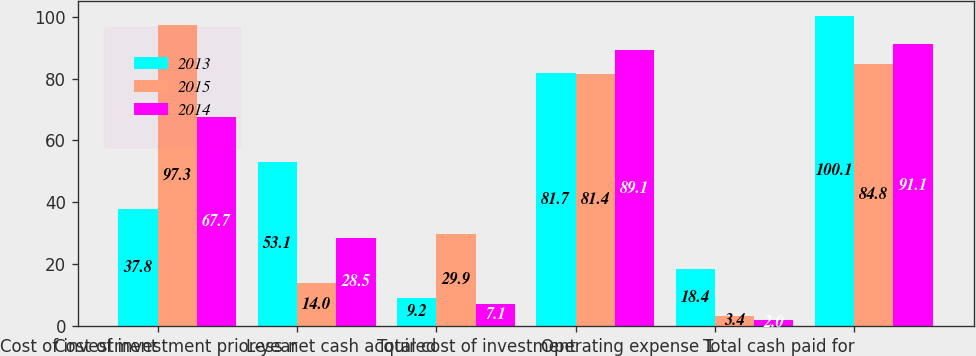<chart> <loc_0><loc_0><loc_500><loc_500><stacked_bar_chart><ecel><fcel>Cost of investment<fcel>Cost of investment prior-year<fcel>Less net cash acquired<fcel>Total cost of investment<fcel>Operating expense 1<fcel>Total cash paid for<nl><fcel>2013<fcel>37.8<fcel>53.1<fcel>9.2<fcel>81.7<fcel>18.4<fcel>100.1<nl><fcel>2015<fcel>97.3<fcel>14<fcel>29.9<fcel>81.4<fcel>3.4<fcel>84.8<nl><fcel>2014<fcel>67.7<fcel>28.5<fcel>7.1<fcel>89.1<fcel>2<fcel>91.1<nl></chart> 